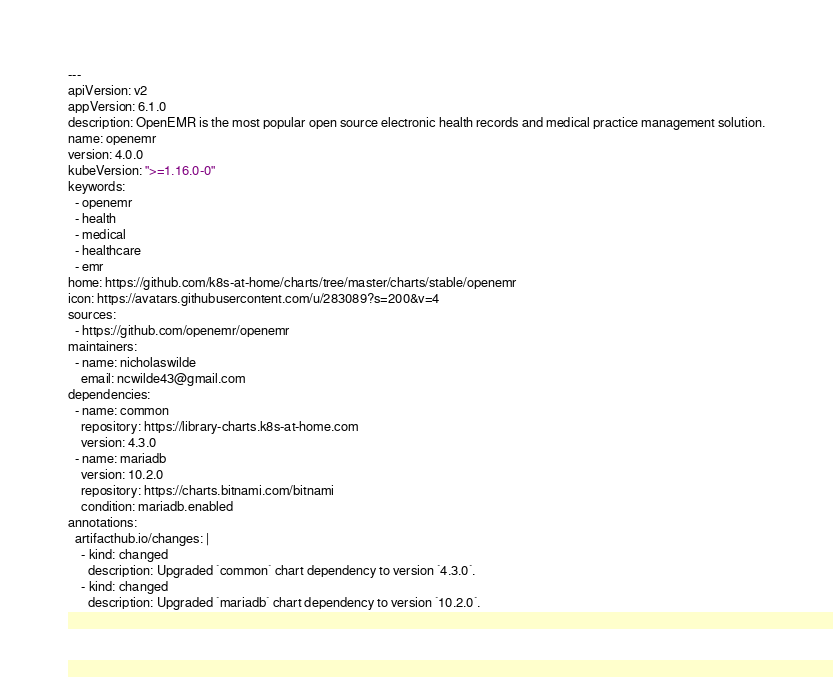<code> <loc_0><loc_0><loc_500><loc_500><_YAML_>---
apiVersion: v2
appVersion: 6.1.0
description: OpenEMR is the most popular open source electronic health records and medical practice management solution.
name: openemr
version: 4.0.0
kubeVersion: ">=1.16.0-0"
keywords:
  - openemr
  - health
  - medical
  - healthcare
  - emr
home: https://github.com/k8s-at-home/charts/tree/master/charts/stable/openemr
icon: https://avatars.githubusercontent.com/u/283089?s=200&v=4
sources:
  - https://github.com/openemr/openemr
maintainers:
  - name: nicholaswilde
    email: ncwilde43@gmail.com
dependencies:
  - name: common
    repository: https://library-charts.k8s-at-home.com
    version: 4.3.0
  - name: mariadb
    version: 10.2.0
    repository: https://charts.bitnami.com/bitnami
    condition: mariadb.enabled
annotations:
  artifacthub.io/changes: |
    - kind: changed
      description: Upgraded `common` chart dependency to version `4.3.0`.
    - kind: changed
      description: Upgraded `mariadb` chart dependency to version `10.2.0`.
</code> 